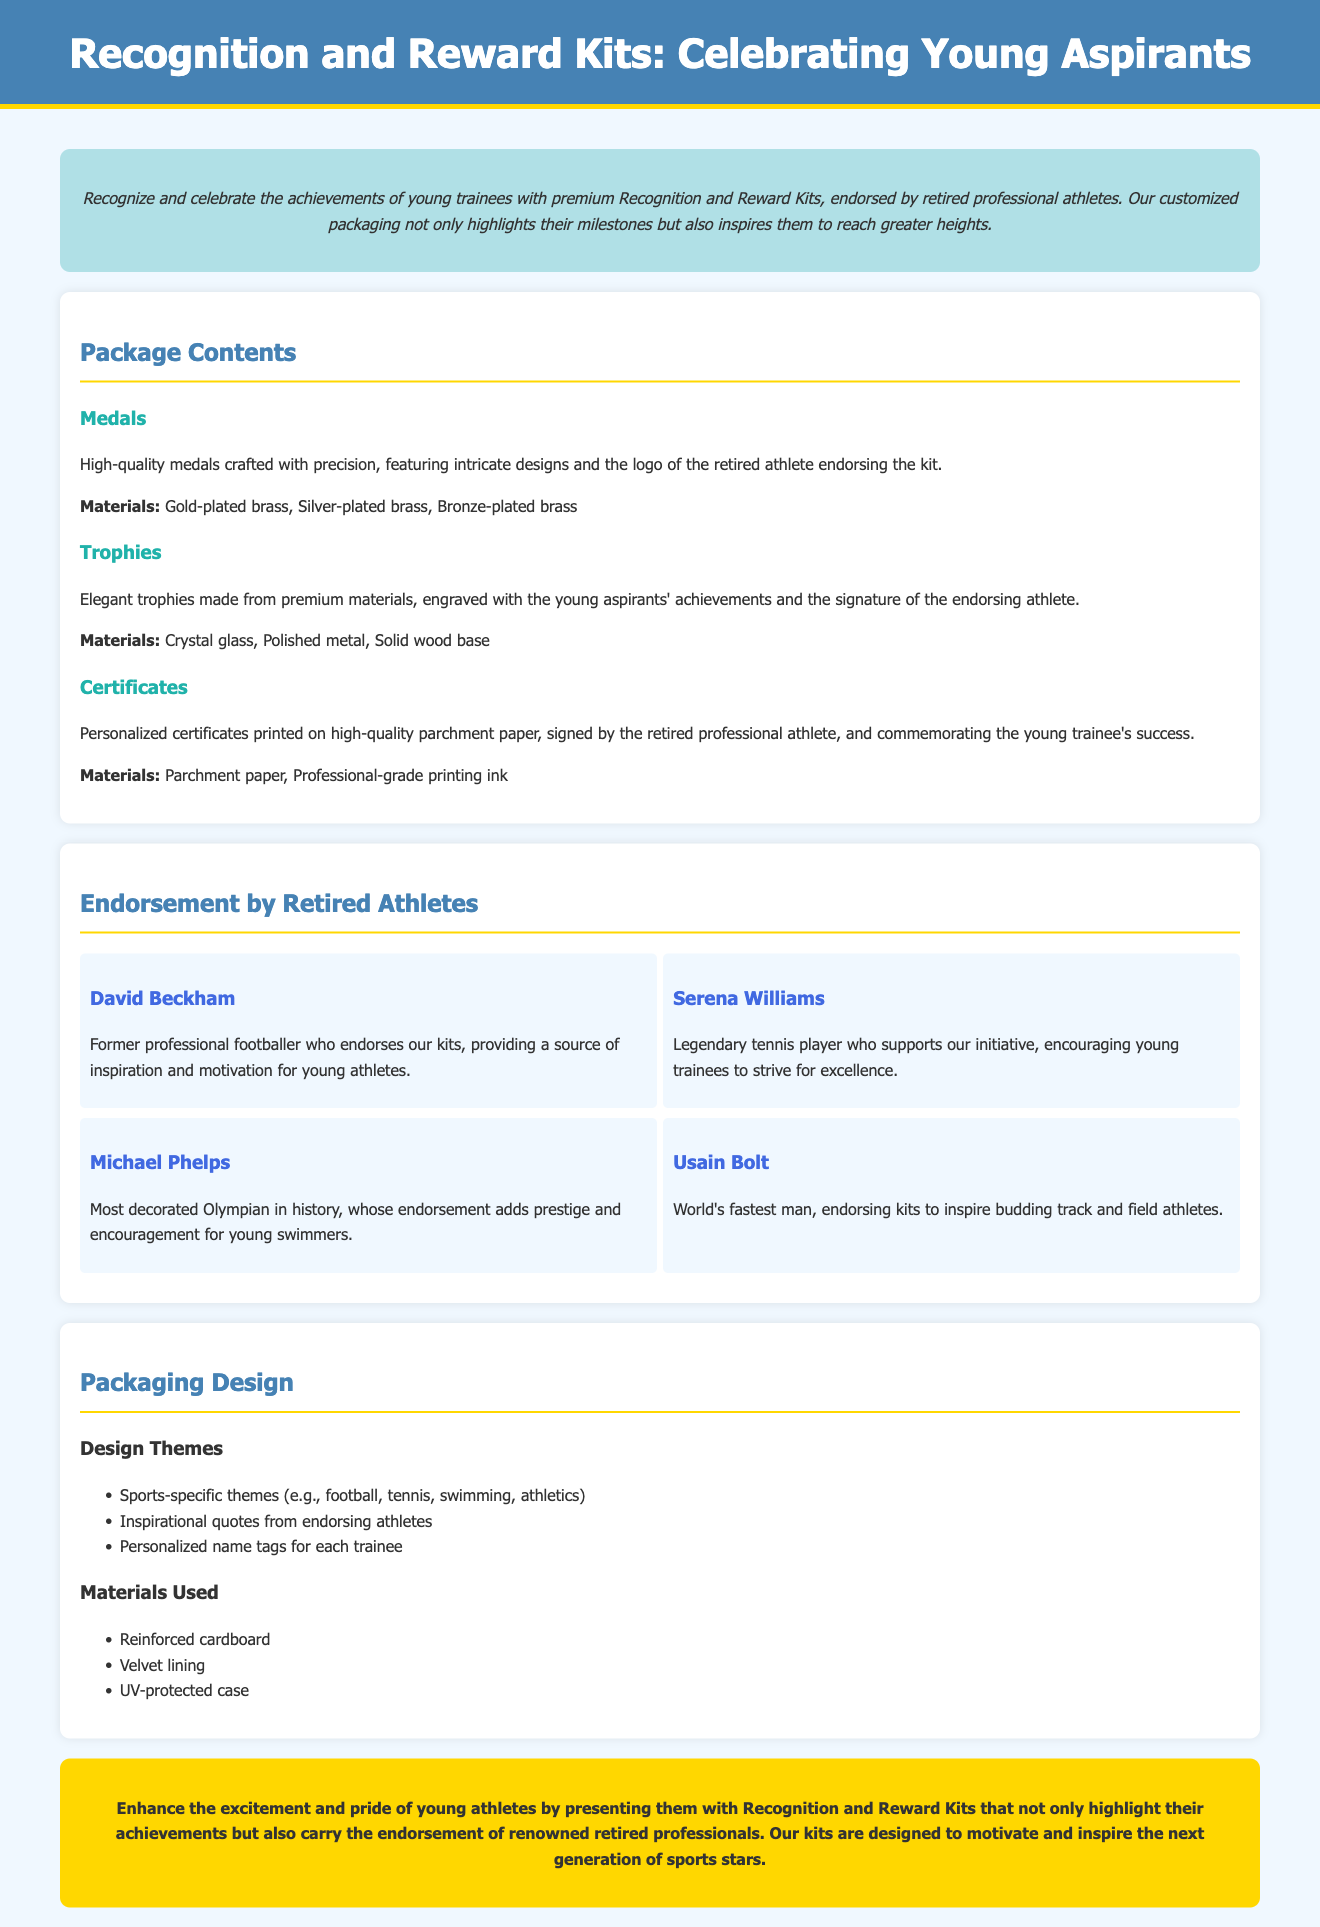what types of awards are included in the kits? The document mentions three types of awards: medals, trophies, and certificates.
Answer: medals, trophies, and certificates who endorses the kits? The document lists retired professional athletes such as David Beckham, Serena Williams, Michael Phelps, and Usain Bolt as endorsers.
Answer: David Beckham, Serena Williams, Michael Phelps, Usain Bolt what material are the medals made of? The document specifies that the medals are made of gold-plated brass, silver-plated brass, and bronze-plated brass.
Answer: gold-plated brass, silver-plated brass, bronze-plated brass how are the certificates described in the document? The document states that the certificates are personalized and printed on high-quality parchment paper, signed by the retired athlete.
Answer: personalized, high-quality parchment paper what is the maximum width of the container in the layout? The document indicates that the container has a maximum width of 1200 pixels.
Answer: 1200 pixels what elements contribute to the packaging design themes? The document mentions sports-specific themes, inspirational quotes, and personalized name tags as elements of the packaging design.
Answer: sports-specific themes, inspirational quotes, personalized name tags which retired athlete is recognized as the most decorated Olympian? The document identifies Michael Phelps as the most decorated Olympian in history.
Answer: Michael Phelps what materials are used for the trophy? The document lists crystal glass, polished metal, and solid wood base as materials for trophies.
Answer: crystal glass, polished metal, solid wood base 